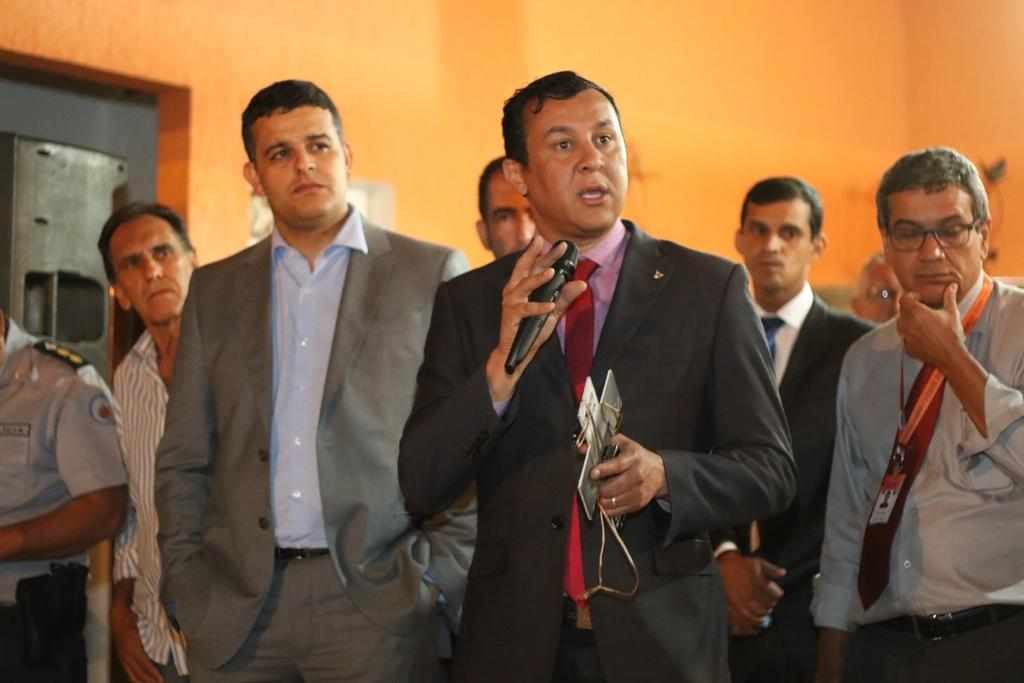How many people are in the image? There is a group of people in the image. What is the man holding in the image? The man is holding a microphone. What is the man doing with the object he is holding? The man is holding an object, which is the microphone. What can be seen in the background of the image? The background of the image includes a wall. How many buildings can be seen in the image? There are no buildings visible in the image. What type of feet are visible in the image? There is no reference to feet in the image. 